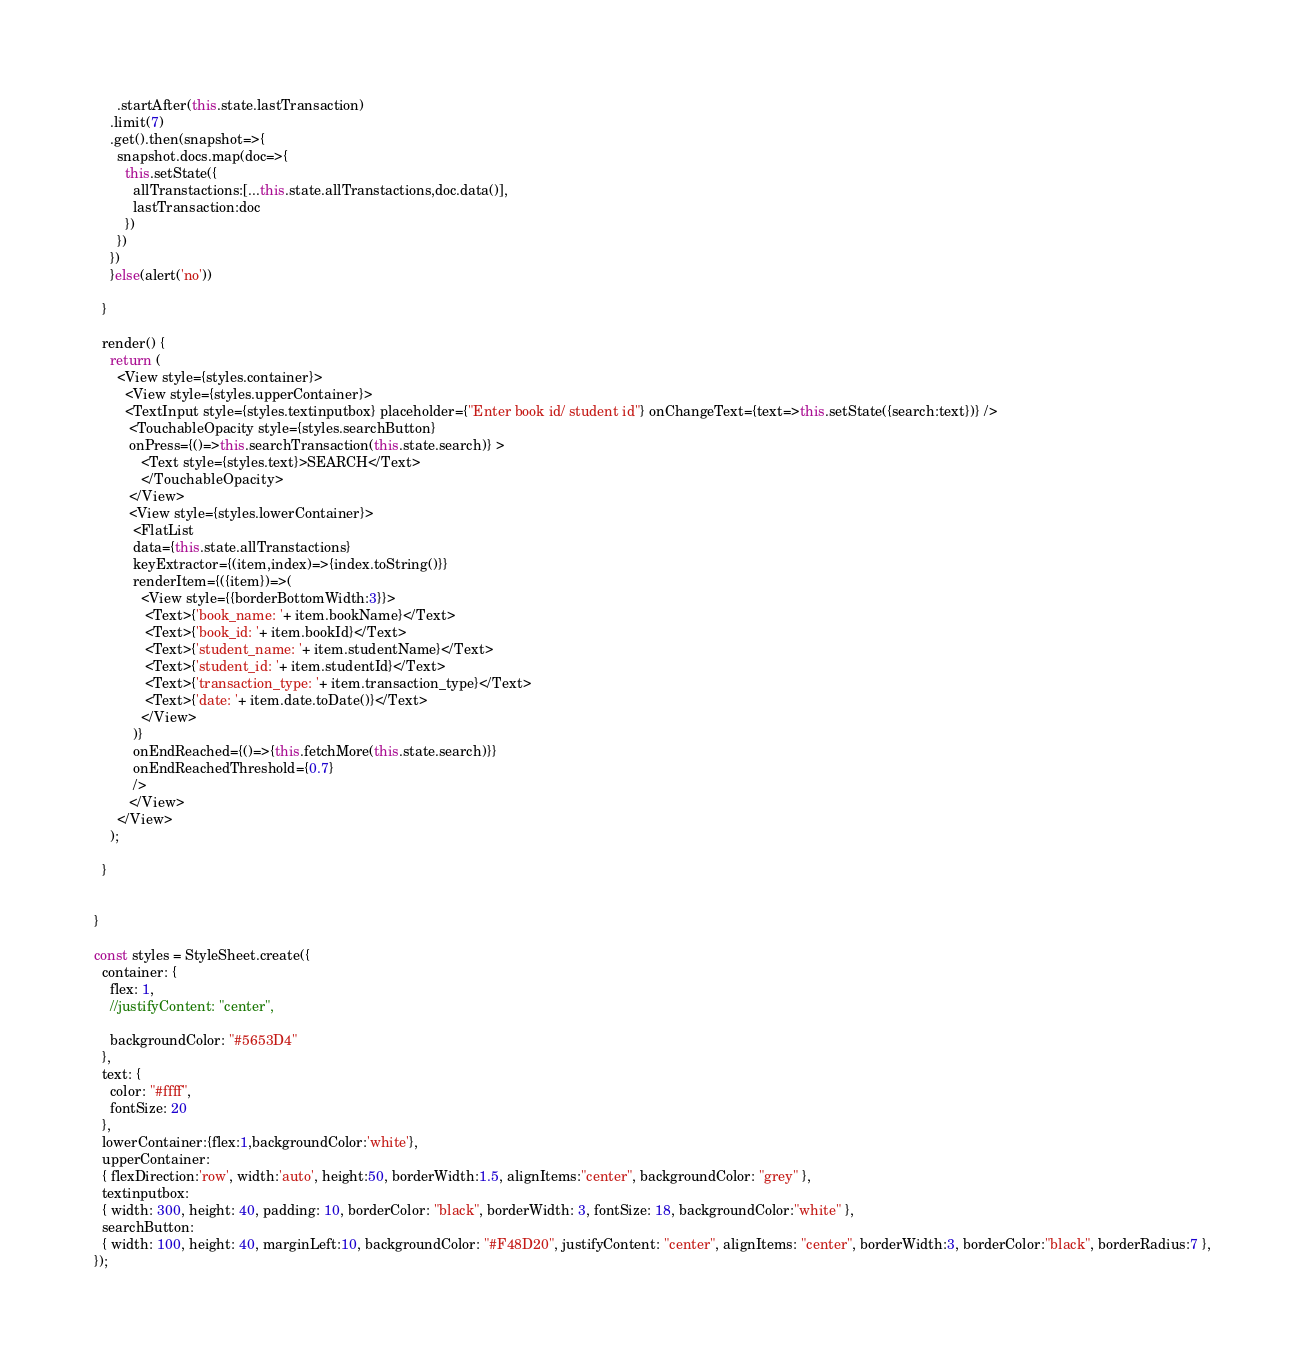Convert code to text. <code><loc_0><loc_0><loc_500><loc_500><_JavaScript_>      .startAfter(this.state.lastTransaction)
    .limit(7)
    .get().then(snapshot=>{
      snapshot.docs.map(doc=>{
        this.setState({
          allTranstactions:[...this.state.allTranstactions,doc.data()],
          lastTransaction:doc
        })
      })
    })
    }else(alert('no'))

  }

  render() {
    return (
      <View style={styles.container}>
        <View style={styles.upperContainer}> 
        <TextInput style={styles.textinputbox} placeholder={"Enter book id/ student id"} onChangeText={text=>this.setState({search:text})} />
         <TouchableOpacity style={styles.searchButton} 
         onPress={()=>this.searchTransaction(this.state.search)} >
            <Text style={styles.text}>SEARCH</Text> 
            </TouchableOpacity>
         </View>
         <View style={styles.lowerContainer}>
          <FlatList 
          data={this.state.allTranstactions}
          keyExtractor={(item,index)=>{index.toString()}}
          renderItem={({item})=>(
            <View style={{borderBottomWidth:3}}>
             <Text>{'book_name: '+ item.bookName}</Text>
             <Text>{'book_id: '+ item.bookId}</Text>
             <Text>{'student_name: '+ item.studentName}</Text>
             <Text>{'student_id: '+ item.studentId}</Text>
             <Text>{'transaction_type: '+ item.transaction_type}</Text>
             <Text>{'date: '+ item.date.toDate()}</Text>
            </View>
          )}
          onEndReached={()=>{this.fetchMore(this.state.search)}}
          onEndReachedThreshold={0.7}
          />
         </View>
      </View>
    ); 

  }


}

const styles = StyleSheet.create({
  container: {
    flex: 1,
    //justifyContent: "center",
    
    backgroundColor: "#5653D4"
  },
  text: {
    color: "#ffff",
    fontSize: 20
  },
  lowerContainer:{flex:1,backgroundColor:'white'},
  upperContainer: 
  { flexDirection:'row', width:'auto', height:50, borderWidth:1.5, alignItems:"center", backgroundColor: "grey" },
  textinputbox: 
  { width: 300, height: 40, padding: 10, borderColor: "black", borderWidth: 3, fontSize: 18, backgroundColor:"white" },
  searchButton: 
  { width: 100, height: 40, marginLeft:10, backgroundColor: "#F48D20", justifyContent: "center", alignItems: "center", borderWidth:3, borderColor:"black", borderRadius:7 },
});
</code> 